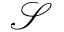Convert formula to latex. <formula><loc_0><loc_0><loc_500><loc_500>\mathcal { S }</formula> 